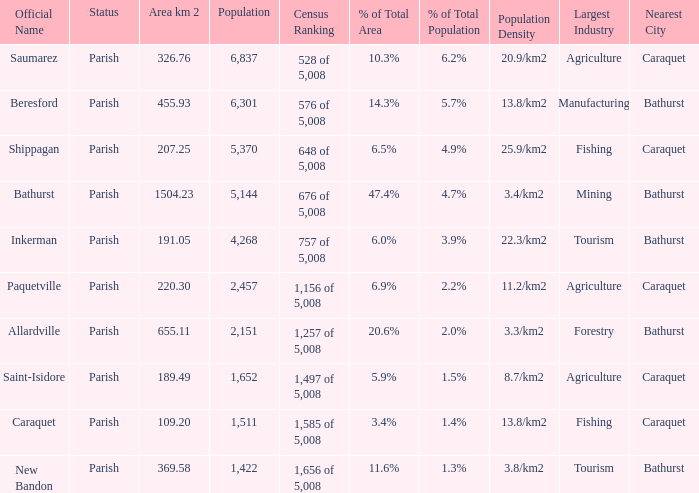What is the Area of the Allardville Parish with a Population smaller than 2,151? None. 